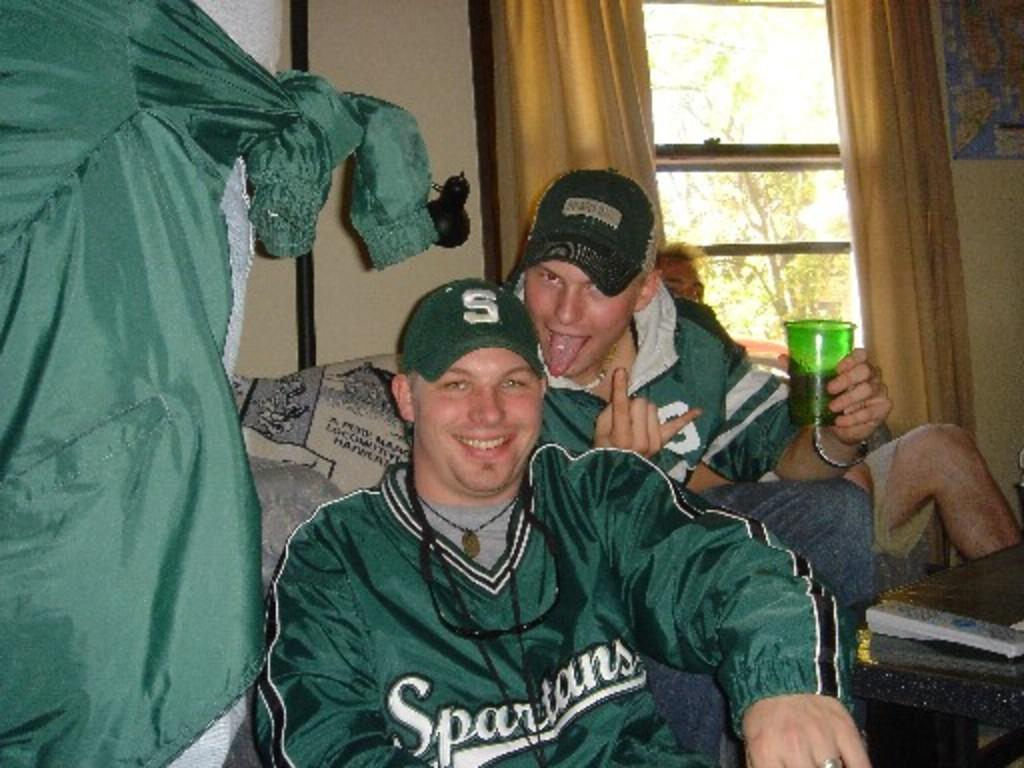<image>
Share a concise interpretation of the image provided. A guy has a hat with a Spartans logo on his hat. 